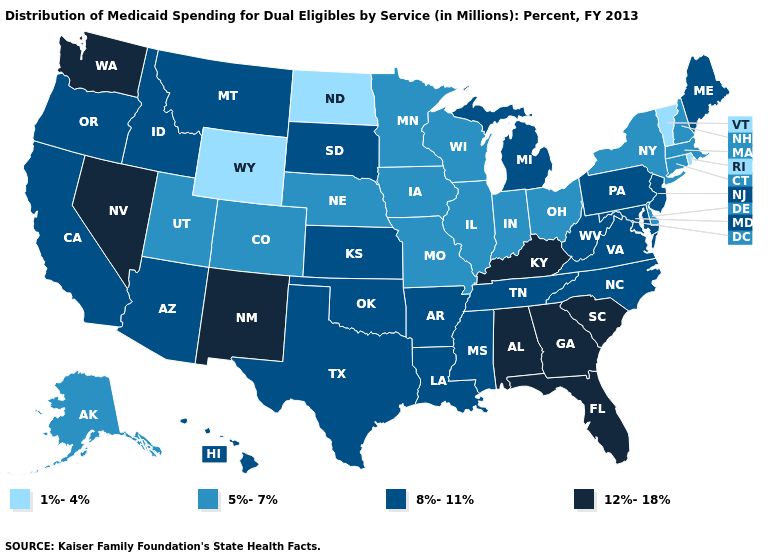Name the states that have a value in the range 1%-4%?
Quick response, please. North Dakota, Rhode Island, Vermont, Wyoming. Does the first symbol in the legend represent the smallest category?
Give a very brief answer. Yes. How many symbols are there in the legend?
Short answer required. 4. What is the lowest value in the MidWest?
Answer briefly. 1%-4%. Does the first symbol in the legend represent the smallest category?
Keep it brief. Yes. Name the states that have a value in the range 8%-11%?
Give a very brief answer. Arizona, Arkansas, California, Hawaii, Idaho, Kansas, Louisiana, Maine, Maryland, Michigan, Mississippi, Montana, New Jersey, North Carolina, Oklahoma, Oregon, Pennsylvania, South Dakota, Tennessee, Texas, Virginia, West Virginia. Which states have the lowest value in the MidWest?
Short answer required. North Dakota. Does the first symbol in the legend represent the smallest category?
Concise answer only. Yes. Which states hav the highest value in the MidWest?
Quick response, please. Kansas, Michigan, South Dakota. Does the first symbol in the legend represent the smallest category?
Keep it brief. Yes. Does Pennsylvania have the highest value in the Northeast?
Write a very short answer. Yes. Name the states that have a value in the range 8%-11%?
Quick response, please. Arizona, Arkansas, California, Hawaii, Idaho, Kansas, Louisiana, Maine, Maryland, Michigan, Mississippi, Montana, New Jersey, North Carolina, Oklahoma, Oregon, Pennsylvania, South Dakota, Tennessee, Texas, Virginia, West Virginia. Among the states that border Missouri , does Kentucky have the highest value?
Quick response, please. Yes. How many symbols are there in the legend?
Be succinct. 4. Does the map have missing data?
Answer briefly. No. 